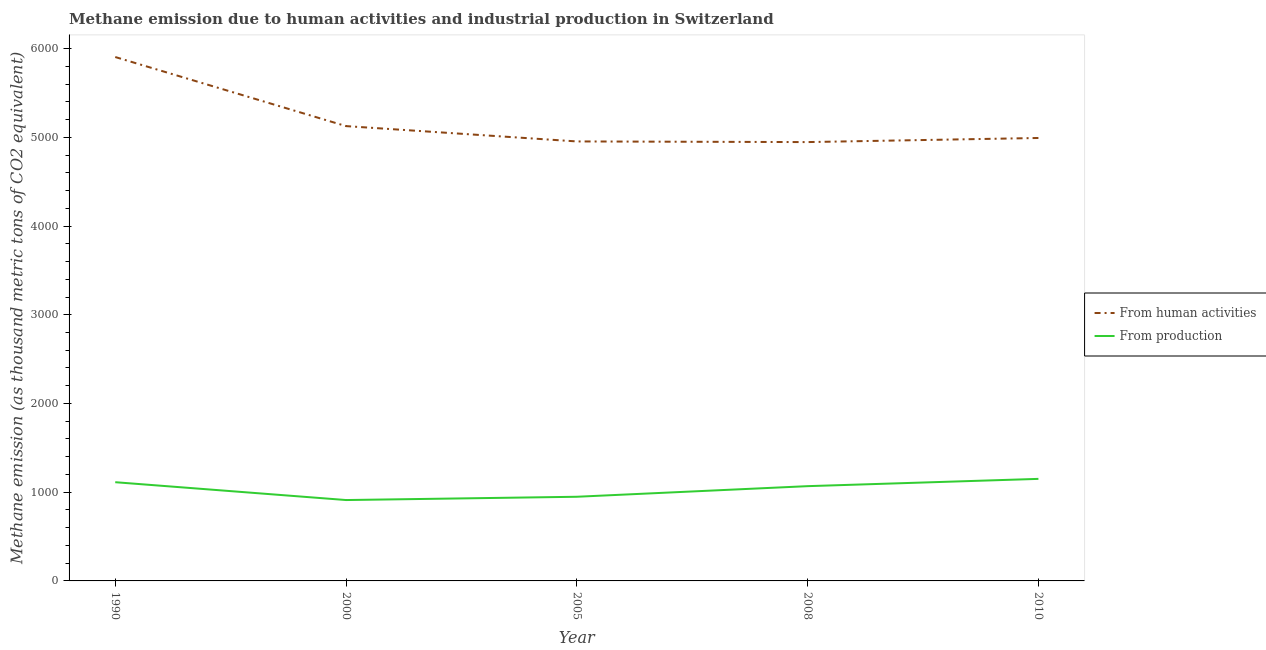Does the line corresponding to amount of emissions from human activities intersect with the line corresponding to amount of emissions generated from industries?
Your answer should be compact. No. Is the number of lines equal to the number of legend labels?
Keep it short and to the point. Yes. What is the amount of emissions from human activities in 2000?
Provide a succinct answer. 5126.2. Across all years, what is the maximum amount of emissions from human activities?
Your response must be concise. 5904.8. Across all years, what is the minimum amount of emissions generated from industries?
Provide a succinct answer. 911.6. In which year was the amount of emissions from human activities minimum?
Offer a very short reply. 2008. What is the total amount of emissions generated from industries in the graph?
Ensure brevity in your answer.  5191.2. What is the difference between the amount of emissions from human activities in 2000 and that in 2008?
Your answer should be compact. 180.1. What is the difference between the amount of emissions generated from industries in 2000 and the amount of emissions from human activities in 2005?
Provide a succinct answer. -4041.8. What is the average amount of emissions generated from industries per year?
Give a very brief answer. 1038.24. In the year 2000, what is the difference between the amount of emissions generated from industries and amount of emissions from human activities?
Keep it short and to the point. -4214.6. In how many years, is the amount of emissions generated from industries greater than 3400 thousand metric tons?
Provide a short and direct response. 0. What is the ratio of the amount of emissions generated from industries in 2005 to that in 2010?
Make the answer very short. 0.82. Is the amount of emissions from human activities in 2008 less than that in 2010?
Provide a short and direct response. Yes. What is the difference between the highest and the second highest amount of emissions generated from industries?
Provide a succinct answer. 37.5. What is the difference between the highest and the lowest amount of emissions from human activities?
Offer a terse response. 958.7. In how many years, is the amount of emissions from human activities greater than the average amount of emissions from human activities taken over all years?
Provide a short and direct response. 1. Is the sum of the amount of emissions generated from industries in 1990 and 2005 greater than the maximum amount of emissions from human activities across all years?
Provide a succinct answer. No. Is the amount of emissions generated from industries strictly less than the amount of emissions from human activities over the years?
Give a very brief answer. Yes. How many lines are there?
Provide a succinct answer. 2. How many years are there in the graph?
Keep it short and to the point. 5. What is the difference between two consecutive major ticks on the Y-axis?
Your answer should be compact. 1000. Does the graph contain grids?
Your answer should be compact. No. How are the legend labels stacked?
Your response must be concise. Vertical. What is the title of the graph?
Provide a short and direct response. Methane emission due to human activities and industrial production in Switzerland. What is the label or title of the Y-axis?
Provide a succinct answer. Methane emission (as thousand metric tons of CO2 equivalent). What is the Methane emission (as thousand metric tons of CO2 equivalent) in From human activities in 1990?
Offer a terse response. 5904.8. What is the Methane emission (as thousand metric tons of CO2 equivalent) of From production in 1990?
Offer a terse response. 1112.7. What is the Methane emission (as thousand metric tons of CO2 equivalent) in From human activities in 2000?
Provide a succinct answer. 5126.2. What is the Methane emission (as thousand metric tons of CO2 equivalent) in From production in 2000?
Provide a succinct answer. 911.6. What is the Methane emission (as thousand metric tons of CO2 equivalent) in From human activities in 2005?
Offer a terse response. 4953.4. What is the Methane emission (as thousand metric tons of CO2 equivalent) in From production in 2005?
Your answer should be very brief. 948.6. What is the Methane emission (as thousand metric tons of CO2 equivalent) of From human activities in 2008?
Provide a succinct answer. 4946.1. What is the Methane emission (as thousand metric tons of CO2 equivalent) of From production in 2008?
Ensure brevity in your answer.  1068.1. What is the Methane emission (as thousand metric tons of CO2 equivalent) of From human activities in 2010?
Your answer should be very brief. 4992.4. What is the Methane emission (as thousand metric tons of CO2 equivalent) of From production in 2010?
Provide a succinct answer. 1150.2. Across all years, what is the maximum Methane emission (as thousand metric tons of CO2 equivalent) of From human activities?
Give a very brief answer. 5904.8. Across all years, what is the maximum Methane emission (as thousand metric tons of CO2 equivalent) of From production?
Offer a terse response. 1150.2. Across all years, what is the minimum Methane emission (as thousand metric tons of CO2 equivalent) of From human activities?
Offer a terse response. 4946.1. Across all years, what is the minimum Methane emission (as thousand metric tons of CO2 equivalent) of From production?
Keep it short and to the point. 911.6. What is the total Methane emission (as thousand metric tons of CO2 equivalent) in From human activities in the graph?
Your answer should be compact. 2.59e+04. What is the total Methane emission (as thousand metric tons of CO2 equivalent) of From production in the graph?
Your response must be concise. 5191.2. What is the difference between the Methane emission (as thousand metric tons of CO2 equivalent) in From human activities in 1990 and that in 2000?
Your response must be concise. 778.6. What is the difference between the Methane emission (as thousand metric tons of CO2 equivalent) of From production in 1990 and that in 2000?
Your answer should be very brief. 201.1. What is the difference between the Methane emission (as thousand metric tons of CO2 equivalent) of From human activities in 1990 and that in 2005?
Your answer should be very brief. 951.4. What is the difference between the Methane emission (as thousand metric tons of CO2 equivalent) of From production in 1990 and that in 2005?
Keep it short and to the point. 164.1. What is the difference between the Methane emission (as thousand metric tons of CO2 equivalent) in From human activities in 1990 and that in 2008?
Your response must be concise. 958.7. What is the difference between the Methane emission (as thousand metric tons of CO2 equivalent) in From production in 1990 and that in 2008?
Your response must be concise. 44.6. What is the difference between the Methane emission (as thousand metric tons of CO2 equivalent) of From human activities in 1990 and that in 2010?
Provide a short and direct response. 912.4. What is the difference between the Methane emission (as thousand metric tons of CO2 equivalent) in From production in 1990 and that in 2010?
Keep it short and to the point. -37.5. What is the difference between the Methane emission (as thousand metric tons of CO2 equivalent) in From human activities in 2000 and that in 2005?
Make the answer very short. 172.8. What is the difference between the Methane emission (as thousand metric tons of CO2 equivalent) of From production in 2000 and that in 2005?
Your answer should be very brief. -37. What is the difference between the Methane emission (as thousand metric tons of CO2 equivalent) in From human activities in 2000 and that in 2008?
Offer a terse response. 180.1. What is the difference between the Methane emission (as thousand metric tons of CO2 equivalent) of From production in 2000 and that in 2008?
Keep it short and to the point. -156.5. What is the difference between the Methane emission (as thousand metric tons of CO2 equivalent) in From human activities in 2000 and that in 2010?
Offer a terse response. 133.8. What is the difference between the Methane emission (as thousand metric tons of CO2 equivalent) in From production in 2000 and that in 2010?
Make the answer very short. -238.6. What is the difference between the Methane emission (as thousand metric tons of CO2 equivalent) of From human activities in 2005 and that in 2008?
Your answer should be compact. 7.3. What is the difference between the Methane emission (as thousand metric tons of CO2 equivalent) of From production in 2005 and that in 2008?
Give a very brief answer. -119.5. What is the difference between the Methane emission (as thousand metric tons of CO2 equivalent) of From human activities in 2005 and that in 2010?
Keep it short and to the point. -39. What is the difference between the Methane emission (as thousand metric tons of CO2 equivalent) of From production in 2005 and that in 2010?
Ensure brevity in your answer.  -201.6. What is the difference between the Methane emission (as thousand metric tons of CO2 equivalent) in From human activities in 2008 and that in 2010?
Offer a terse response. -46.3. What is the difference between the Methane emission (as thousand metric tons of CO2 equivalent) in From production in 2008 and that in 2010?
Provide a succinct answer. -82.1. What is the difference between the Methane emission (as thousand metric tons of CO2 equivalent) of From human activities in 1990 and the Methane emission (as thousand metric tons of CO2 equivalent) of From production in 2000?
Provide a short and direct response. 4993.2. What is the difference between the Methane emission (as thousand metric tons of CO2 equivalent) of From human activities in 1990 and the Methane emission (as thousand metric tons of CO2 equivalent) of From production in 2005?
Make the answer very short. 4956.2. What is the difference between the Methane emission (as thousand metric tons of CO2 equivalent) in From human activities in 1990 and the Methane emission (as thousand metric tons of CO2 equivalent) in From production in 2008?
Ensure brevity in your answer.  4836.7. What is the difference between the Methane emission (as thousand metric tons of CO2 equivalent) of From human activities in 1990 and the Methane emission (as thousand metric tons of CO2 equivalent) of From production in 2010?
Ensure brevity in your answer.  4754.6. What is the difference between the Methane emission (as thousand metric tons of CO2 equivalent) of From human activities in 2000 and the Methane emission (as thousand metric tons of CO2 equivalent) of From production in 2005?
Offer a terse response. 4177.6. What is the difference between the Methane emission (as thousand metric tons of CO2 equivalent) in From human activities in 2000 and the Methane emission (as thousand metric tons of CO2 equivalent) in From production in 2008?
Make the answer very short. 4058.1. What is the difference between the Methane emission (as thousand metric tons of CO2 equivalent) in From human activities in 2000 and the Methane emission (as thousand metric tons of CO2 equivalent) in From production in 2010?
Give a very brief answer. 3976. What is the difference between the Methane emission (as thousand metric tons of CO2 equivalent) in From human activities in 2005 and the Methane emission (as thousand metric tons of CO2 equivalent) in From production in 2008?
Offer a very short reply. 3885.3. What is the difference between the Methane emission (as thousand metric tons of CO2 equivalent) of From human activities in 2005 and the Methane emission (as thousand metric tons of CO2 equivalent) of From production in 2010?
Provide a short and direct response. 3803.2. What is the difference between the Methane emission (as thousand metric tons of CO2 equivalent) in From human activities in 2008 and the Methane emission (as thousand metric tons of CO2 equivalent) in From production in 2010?
Keep it short and to the point. 3795.9. What is the average Methane emission (as thousand metric tons of CO2 equivalent) of From human activities per year?
Offer a very short reply. 5184.58. What is the average Methane emission (as thousand metric tons of CO2 equivalent) in From production per year?
Provide a short and direct response. 1038.24. In the year 1990, what is the difference between the Methane emission (as thousand metric tons of CO2 equivalent) in From human activities and Methane emission (as thousand metric tons of CO2 equivalent) in From production?
Your response must be concise. 4792.1. In the year 2000, what is the difference between the Methane emission (as thousand metric tons of CO2 equivalent) in From human activities and Methane emission (as thousand metric tons of CO2 equivalent) in From production?
Your response must be concise. 4214.6. In the year 2005, what is the difference between the Methane emission (as thousand metric tons of CO2 equivalent) of From human activities and Methane emission (as thousand metric tons of CO2 equivalent) of From production?
Offer a terse response. 4004.8. In the year 2008, what is the difference between the Methane emission (as thousand metric tons of CO2 equivalent) of From human activities and Methane emission (as thousand metric tons of CO2 equivalent) of From production?
Your response must be concise. 3878. In the year 2010, what is the difference between the Methane emission (as thousand metric tons of CO2 equivalent) in From human activities and Methane emission (as thousand metric tons of CO2 equivalent) in From production?
Give a very brief answer. 3842.2. What is the ratio of the Methane emission (as thousand metric tons of CO2 equivalent) of From human activities in 1990 to that in 2000?
Your answer should be very brief. 1.15. What is the ratio of the Methane emission (as thousand metric tons of CO2 equivalent) of From production in 1990 to that in 2000?
Your response must be concise. 1.22. What is the ratio of the Methane emission (as thousand metric tons of CO2 equivalent) in From human activities in 1990 to that in 2005?
Your response must be concise. 1.19. What is the ratio of the Methane emission (as thousand metric tons of CO2 equivalent) in From production in 1990 to that in 2005?
Your response must be concise. 1.17. What is the ratio of the Methane emission (as thousand metric tons of CO2 equivalent) of From human activities in 1990 to that in 2008?
Offer a terse response. 1.19. What is the ratio of the Methane emission (as thousand metric tons of CO2 equivalent) in From production in 1990 to that in 2008?
Offer a very short reply. 1.04. What is the ratio of the Methane emission (as thousand metric tons of CO2 equivalent) in From human activities in 1990 to that in 2010?
Keep it short and to the point. 1.18. What is the ratio of the Methane emission (as thousand metric tons of CO2 equivalent) in From production in 1990 to that in 2010?
Give a very brief answer. 0.97. What is the ratio of the Methane emission (as thousand metric tons of CO2 equivalent) of From human activities in 2000 to that in 2005?
Make the answer very short. 1.03. What is the ratio of the Methane emission (as thousand metric tons of CO2 equivalent) in From human activities in 2000 to that in 2008?
Provide a succinct answer. 1.04. What is the ratio of the Methane emission (as thousand metric tons of CO2 equivalent) in From production in 2000 to that in 2008?
Your response must be concise. 0.85. What is the ratio of the Methane emission (as thousand metric tons of CO2 equivalent) of From human activities in 2000 to that in 2010?
Keep it short and to the point. 1.03. What is the ratio of the Methane emission (as thousand metric tons of CO2 equivalent) in From production in 2000 to that in 2010?
Your response must be concise. 0.79. What is the ratio of the Methane emission (as thousand metric tons of CO2 equivalent) of From production in 2005 to that in 2008?
Give a very brief answer. 0.89. What is the ratio of the Methane emission (as thousand metric tons of CO2 equivalent) in From human activities in 2005 to that in 2010?
Offer a terse response. 0.99. What is the ratio of the Methane emission (as thousand metric tons of CO2 equivalent) of From production in 2005 to that in 2010?
Keep it short and to the point. 0.82. What is the ratio of the Methane emission (as thousand metric tons of CO2 equivalent) of From human activities in 2008 to that in 2010?
Give a very brief answer. 0.99. What is the ratio of the Methane emission (as thousand metric tons of CO2 equivalent) of From production in 2008 to that in 2010?
Offer a very short reply. 0.93. What is the difference between the highest and the second highest Methane emission (as thousand metric tons of CO2 equivalent) in From human activities?
Offer a very short reply. 778.6. What is the difference between the highest and the second highest Methane emission (as thousand metric tons of CO2 equivalent) of From production?
Give a very brief answer. 37.5. What is the difference between the highest and the lowest Methane emission (as thousand metric tons of CO2 equivalent) in From human activities?
Your response must be concise. 958.7. What is the difference between the highest and the lowest Methane emission (as thousand metric tons of CO2 equivalent) in From production?
Keep it short and to the point. 238.6. 